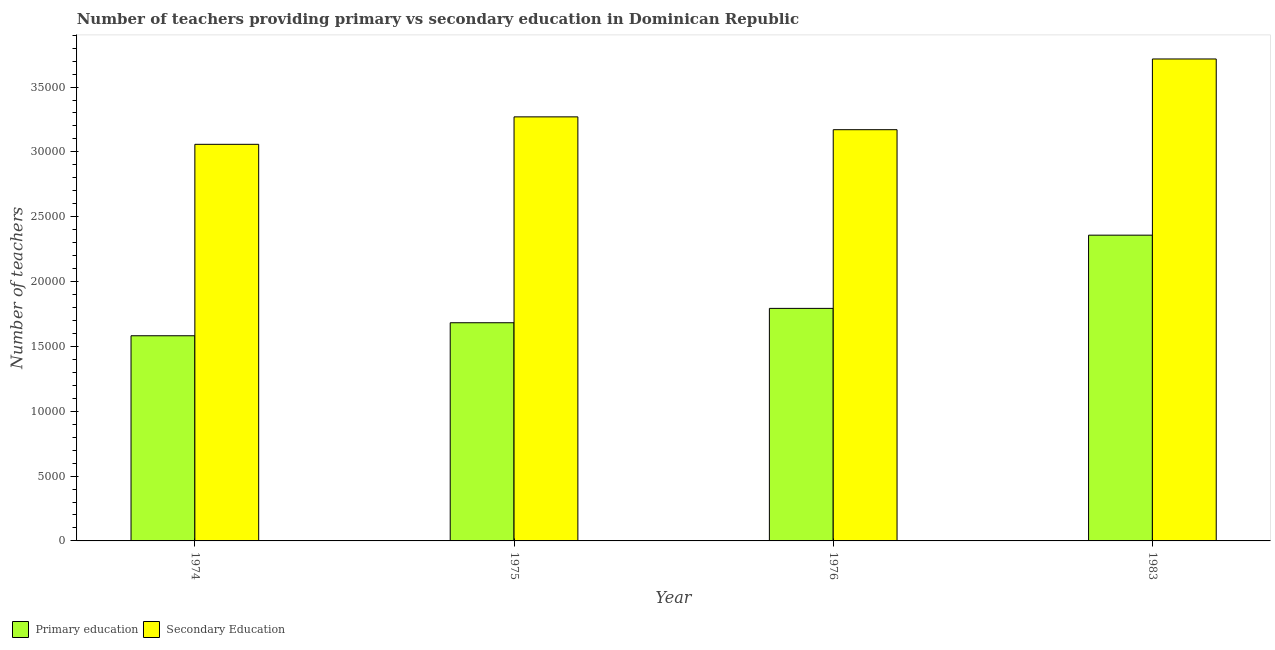How many different coloured bars are there?
Offer a very short reply. 2. Are the number of bars per tick equal to the number of legend labels?
Offer a terse response. Yes. What is the label of the 1st group of bars from the left?
Make the answer very short. 1974. In how many cases, is the number of bars for a given year not equal to the number of legend labels?
Provide a succinct answer. 0. What is the number of primary teachers in 1976?
Provide a succinct answer. 1.79e+04. Across all years, what is the maximum number of primary teachers?
Offer a very short reply. 2.36e+04. Across all years, what is the minimum number of primary teachers?
Keep it short and to the point. 1.58e+04. In which year was the number of secondary teachers maximum?
Provide a short and direct response. 1983. In which year was the number of secondary teachers minimum?
Keep it short and to the point. 1974. What is the total number of secondary teachers in the graph?
Make the answer very short. 1.32e+05. What is the difference between the number of secondary teachers in 1974 and that in 1975?
Your answer should be compact. -2117. What is the difference between the number of secondary teachers in 1975 and the number of primary teachers in 1974?
Provide a succinct answer. 2117. What is the average number of primary teachers per year?
Offer a very short reply. 1.85e+04. What is the ratio of the number of primary teachers in 1974 to that in 1975?
Make the answer very short. 0.94. Is the number of primary teachers in 1976 less than that in 1983?
Offer a very short reply. Yes. What is the difference between the highest and the second highest number of primary teachers?
Your answer should be compact. 5646. What is the difference between the highest and the lowest number of secondary teachers?
Keep it short and to the point. 6581. What does the 2nd bar from the left in 1983 represents?
Provide a short and direct response. Secondary Education. What does the 1st bar from the right in 1975 represents?
Ensure brevity in your answer.  Secondary Education. Are all the bars in the graph horizontal?
Provide a succinct answer. No. How many years are there in the graph?
Offer a very short reply. 4. What is the difference between two consecutive major ticks on the Y-axis?
Offer a very short reply. 5000. Where does the legend appear in the graph?
Ensure brevity in your answer.  Bottom left. How many legend labels are there?
Offer a terse response. 2. How are the legend labels stacked?
Offer a very short reply. Horizontal. What is the title of the graph?
Offer a very short reply. Number of teachers providing primary vs secondary education in Dominican Republic. Does "Underweight" appear as one of the legend labels in the graph?
Offer a terse response. No. What is the label or title of the X-axis?
Your answer should be very brief. Year. What is the label or title of the Y-axis?
Your response must be concise. Number of teachers. What is the Number of teachers in Primary education in 1974?
Ensure brevity in your answer.  1.58e+04. What is the Number of teachers of Secondary Education in 1974?
Keep it short and to the point. 3.06e+04. What is the Number of teachers in Primary education in 1975?
Make the answer very short. 1.68e+04. What is the Number of teachers in Secondary Education in 1975?
Your answer should be compact. 3.27e+04. What is the Number of teachers of Primary education in 1976?
Offer a very short reply. 1.79e+04. What is the Number of teachers of Secondary Education in 1976?
Offer a terse response. 3.17e+04. What is the Number of teachers in Primary education in 1983?
Provide a short and direct response. 2.36e+04. What is the Number of teachers in Secondary Education in 1983?
Offer a terse response. 3.72e+04. Across all years, what is the maximum Number of teachers in Primary education?
Provide a succinct answer. 2.36e+04. Across all years, what is the maximum Number of teachers in Secondary Education?
Your answer should be very brief. 3.72e+04. Across all years, what is the minimum Number of teachers of Primary education?
Make the answer very short. 1.58e+04. Across all years, what is the minimum Number of teachers of Secondary Education?
Offer a very short reply. 3.06e+04. What is the total Number of teachers in Primary education in the graph?
Your answer should be compact. 7.42e+04. What is the total Number of teachers of Secondary Education in the graph?
Make the answer very short. 1.32e+05. What is the difference between the Number of teachers of Primary education in 1974 and that in 1975?
Give a very brief answer. -1003. What is the difference between the Number of teachers of Secondary Education in 1974 and that in 1975?
Your response must be concise. -2117. What is the difference between the Number of teachers in Primary education in 1974 and that in 1976?
Offer a terse response. -2111. What is the difference between the Number of teachers in Secondary Education in 1974 and that in 1976?
Provide a succinct answer. -1127. What is the difference between the Number of teachers in Primary education in 1974 and that in 1983?
Offer a terse response. -7757. What is the difference between the Number of teachers in Secondary Education in 1974 and that in 1983?
Ensure brevity in your answer.  -6581. What is the difference between the Number of teachers in Primary education in 1975 and that in 1976?
Offer a very short reply. -1108. What is the difference between the Number of teachers in Secondary Education in 1975 and that in 1976?
Provide a short and direct response. 990. What is the difference between the Number of teachers of Primary education in 1975 and that in 1983?
Offer a terse response. -6754. What is the difference between the Number of teachers of Secondary Education in 1975 and that in 1983?
Provide a succinct answer. -4464. What is the difference between the Number of teachers of Primary education in 1976 and that in 1983?
Offer a very short reply. -5646. What is the difference between the Number of teachers in Secondary Education in 1976 and that in 1983?
Provide a succinct answer. -5454. What is the difference between the Number of teachers of Primary education in 1974 and the Number of teachers of Secondary Education in 1975?
Make the answer very short. -1.69e+04. What is the difference between the Number of teachers of Primary education in 1974 and the Number of teachers of Secondary Education in 1976?
Keep it short and to the point. -1.59e+04. What is the difference between the Number of teachers of Primary education in 1974 and the Number of teachers of Secondary Education in 1983?
Offer a very short reply. -2.13e+04. What is the difference between the Number of teachers of Primary education in 1975 and the Number of teachers of Secondary Education in 1976?
Your answer should be very brief. -1.49e+04. What is the difference between the Number of teachers in Primary education in 1975 and the Number of teachers in Secondary Education in 1983?
Offer a very short reply. -2.03e+04. What is the difference between the Number of teachers of Primary education in 1976 and the Number of teachers of Secondary Education in 1983?
Give a very brief answer. -1.92e+04. What is the average Number of teachers of Primary education per year?
Keep it short and to the point. 1.85e+04. What is the average Number of teachers of Secondary Education per year?
Offer a terse response. 3.30e+04. In the year 1974, what is the difference between the Number of teachers of Primary education and Number of teachers of Secondary Education?
Your response must be concise. -1.48e+04. In the year 1975, what is the difference between the Number of teachers of Primary education and Number of teachers of Secondary Education?
Your answer should be very brief. -1.59e+04. In the year 1976, what is the difference between the Number of teachers in Primary education and Number of teachers in Secondary Education?
Ensure brevity in your answer.  -1.38e+04. In the year 1983, what is the difference between the Number of teachers in Primary education and Number of teachers in Secondary Education?
Offer a terse response. -1.36e+04. What is the ratio of the Number of teachers in Primary education in 1974 to that in 1975?
Your response must be concise. 0.94. What is the ratio of the Number of teachers of Secondary Education in 1974 to that in 1975?
Give a very brief answer. 0.94. What is the ratio of the Number of teachers in Primary education in 1974 to that in 1976?
Provide a short and direct response. 0.88. What is the ratio of the Number of teachers of Secondary Education in 1974 to that in 1976?
Your response must be concise. 0.96. What is the ratio of the Number of teachers of Primary education in 1974 to that in 1983?
Provide a succinct answer. 0.67. What is the ratio of the Number of teachers in Secondary Education in 1974 to that in 1983?
Your answer should be compact. 0.82. What is the ratio of the Number of teachers in Primary education in 1975 to that in 1976?
Your answer should be compact. 0.94. What is the ratio of the Number of teachers of Secondary Education in 1975 to that in 1976?
Your answer should be compact. 1.03. What is the ratio of the Number of teachers in Primary education in 1975 to that in 1983?
Your response must be concise. 0.71. What is the ratio of the Number of teachers of Secondary Education in 1975 to that in 1983?
Make the answer very short. 0.88. What is the ratio of the Number of teachers in Primary education in 1976 to that in 1983?
Provide a short and direct response. 0.76. What is the ratio of the Number of teachers in Secondary Education in 1976 to that in 1983?
Give a very brief answer. 0.85. What is the difference between the highest and the second highest Number of teachers in Primary education?
Provide a short and direct response. 5646. What is the difference between the highest and the second highest Number of teachers of Secondary Education?
Make the answer very short. 4464. What is the difference between the highest and the lowest Number of teachers of Primary education?
Keep it short and to the point. 7757. What is the difference between the highest and the lowest Number of teachers in Secondary Education?
Provide a short and direct response. 6581. 